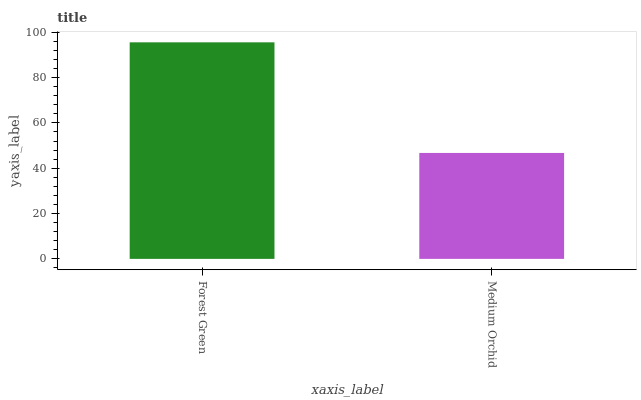Is Medium Orchid the maximum?
Answer yes or no. No. Is Forest Green greater than Medium Orchid?
Answer yes or no. Yes. Is Medium Orchid less than Forest Green?
Answer yes or no. Yes. Is Medium Orchid greater than Forest Green?
Answer yes or no. No. Is Forest Green less than Medium Orchid?
Answer yes or no. No. Is Forest Green the high median?
Answer yes or no. Yes. Is Medium Orchid the low median?
Answer yes or no. Yes. Is Medium Orchid the high median?
Answer yes or no. No. Is Forest Green the low median?
Answer yes or no. No. 